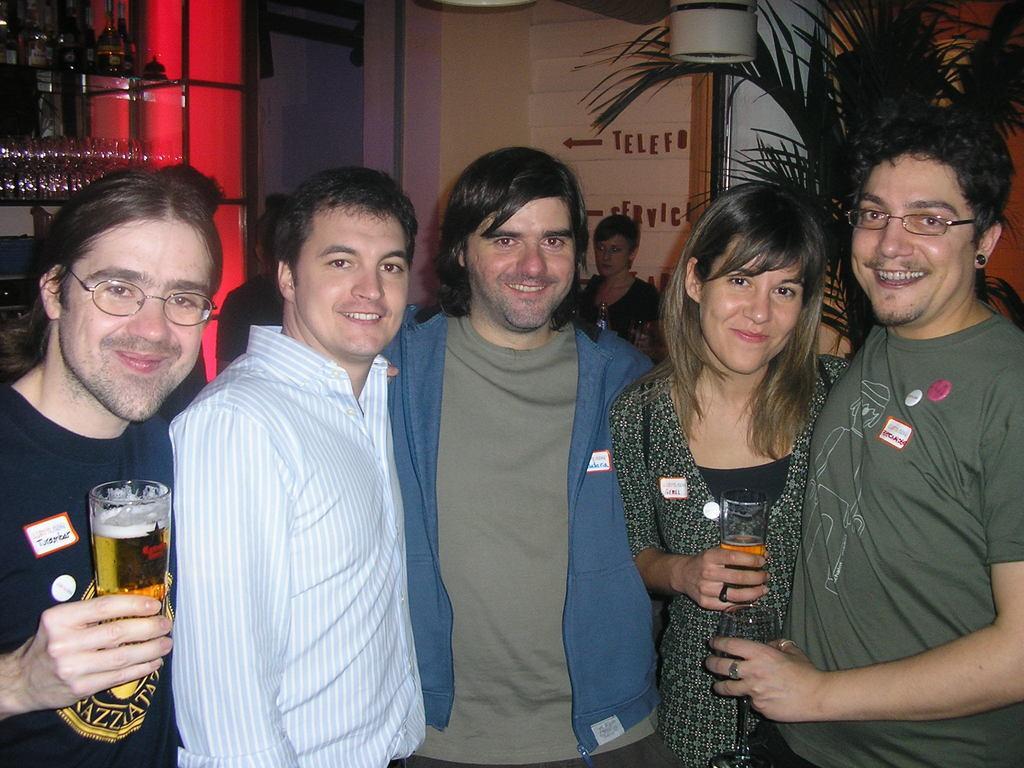Please provide a concise description of this image. There are five people standing in front of the image and everyone is smiling. The first left guy is holding a beer glass in his hand. There is a wall in the background and also women standing there. This is the tree or plant placed back side of the image. 